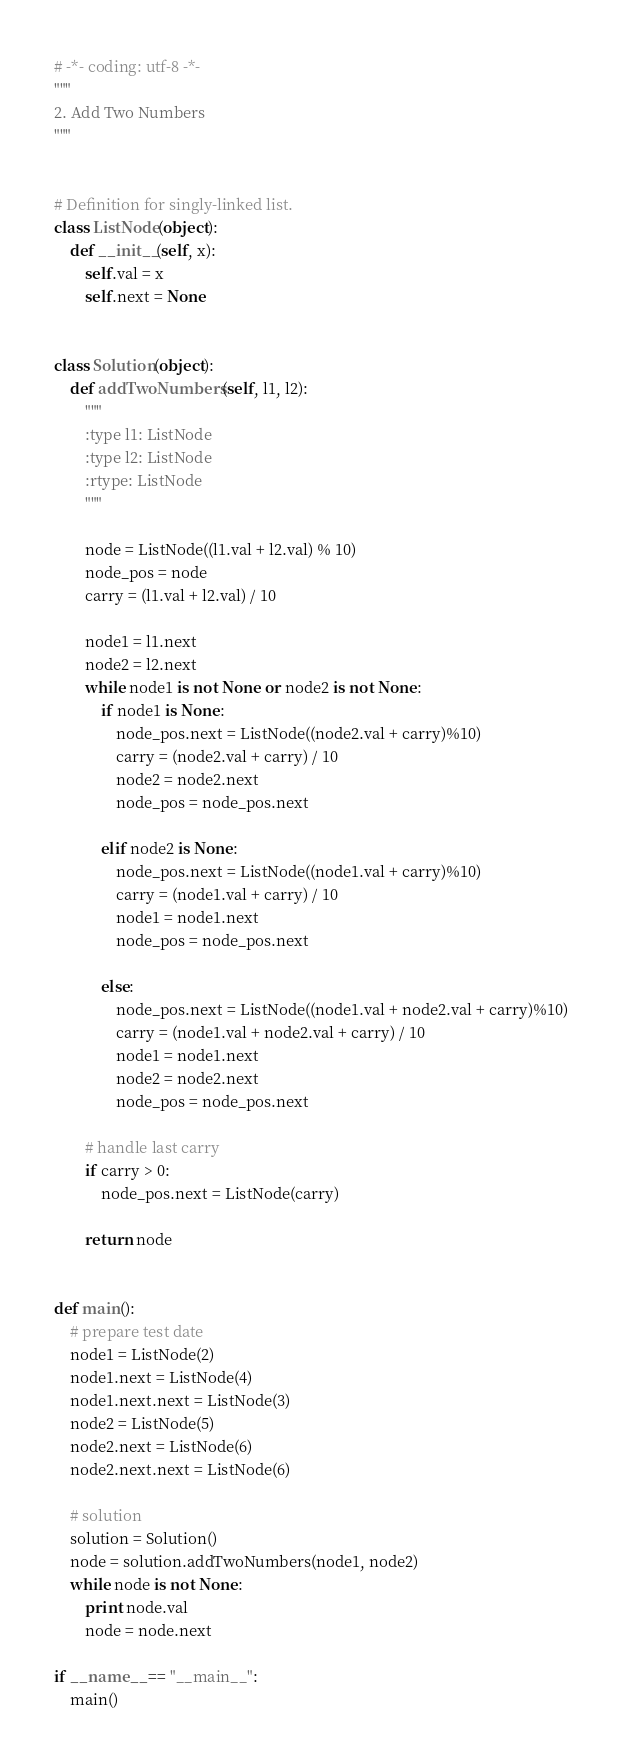<code> <loc_0><loc_0><loc_500><loc_500><_Python_># -*- coding: utf-8 -*-
"""
2. Add Two Numbers
"""


# Definition for singly-linked list.
class ListNode(object):
    def __init__(self, x):
        self.val = x
        self.next = None


class Solution(object):
    def addTwoNumbers(self, l1, l2):
        """
        :type l1: ListNode
        :type l2: ListNode
        :rtype: ListNode
        """

        node = ListNode((l1.val + l2.val) % 10)
        node_pos = node
        carry = (l1.val + l2.val) / 10

        node1 = l1.next
        node2 = l2.next
        while node1 is not None or node2 is not None:
            if node1 is None:
                node_pos.next = ListNode((node2.val + carry)%10)
                carry = (node2.val + carry) / 10
                node2 = node2.next
                node_pos = node_pos.next

            elif node2 is None:
                node_pos.next = ListNode((node1.val + carry)%10)
                carry = (node1.val + carry) / 10
                node1 = node1.next
                node_pos = node_pos.next

            else:
                node_pos.next = ListNode((node1.val + node2.val + carry)%10)
                carry = (node1.val + node2.val + carry) / 10
                node1 = node1.next
                node2 = node2.next
                node_pos = node_pos.next

        # handle last carry
        if carry > 0:
            node_pos.next = ListNode(carry)

        return node


def main():
    # prepare test date
    node1 = ListNode(2)
    node1.next = ListNode(4)
    node1.next.next = ListNode(3)
    node2 = ListNode(5)
    node2.next = ListNode(6)
    node2.next.next = ListNode(6)

    # solution
    solution = Solution()
    node = solution.addTwoNumbers(node1, node2)
    while node is not None:
        print node.val
        node = node.next

if __name__ == "__main__":
    main()
</code> 